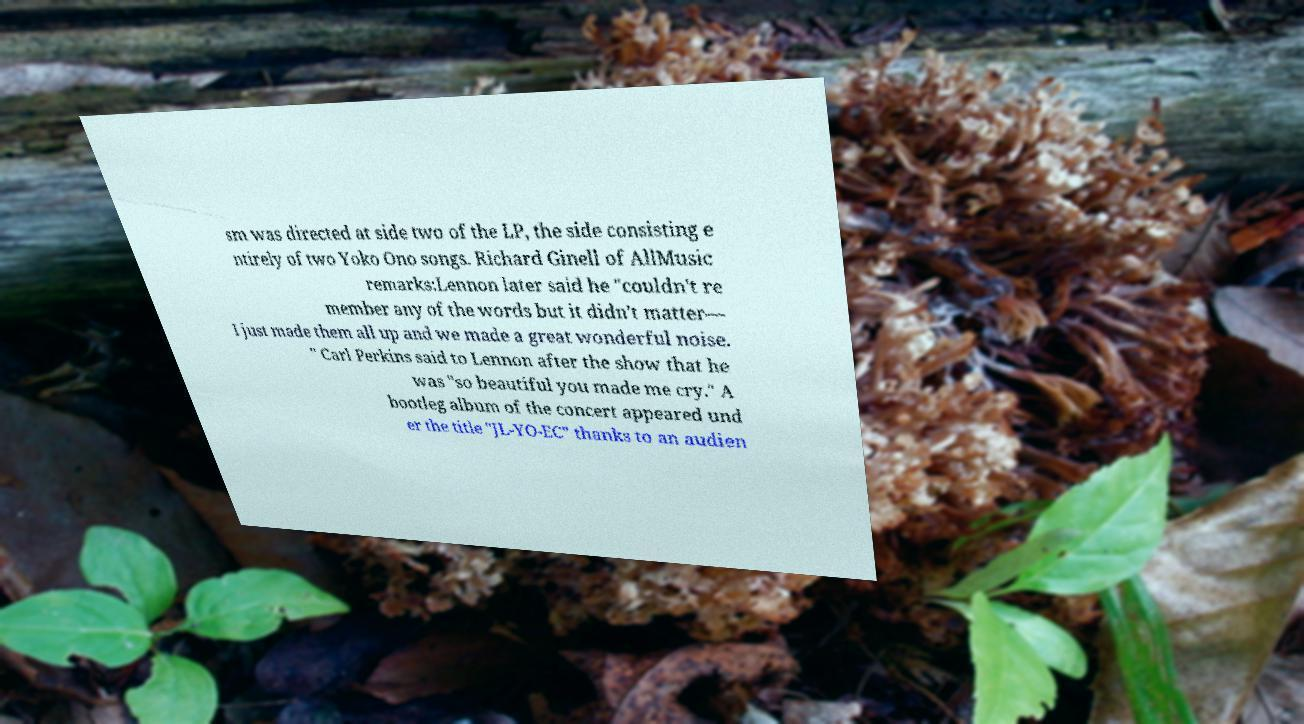Can you read and provide the text displayed in the image?This photo seems to have some interesting text. Can you extract and type it out for me? sm was directed at side two of the LP, the side consisting e ntirely of two Yoko Ono songs. Richard Ginell of AllMusic remarks:Lennon later said he "couldn't re member any of the words but it didn't matter— I just made them all up and we made a great wonderful noise. " Carl Perkins said to Lennon after the show that he was "so beautiful you made me cry." A bootleg album of the concert appeared und er the title "JL-YO-EC" thanks to an audien 